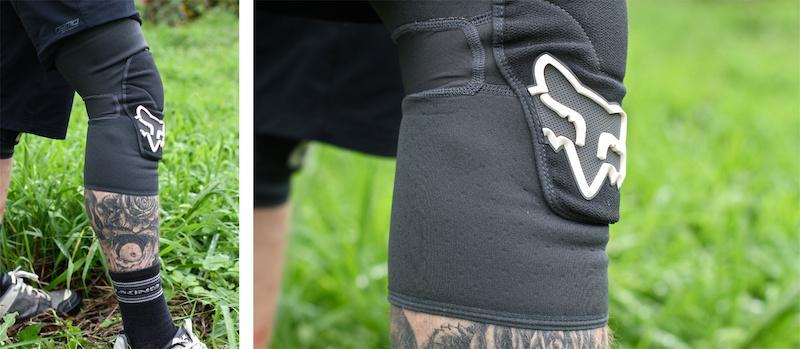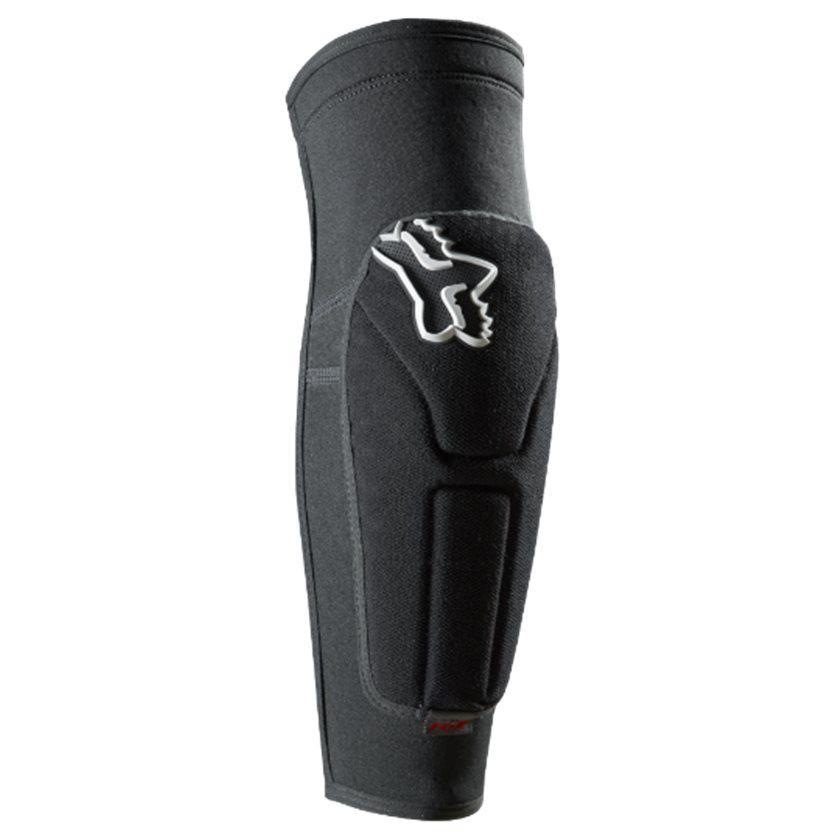The first image is the image on the left, the second image is the image on the right. Given the left and right images, does the statement "both knee pads are black and shown unworn" hold true? Answer yes or no. No. 